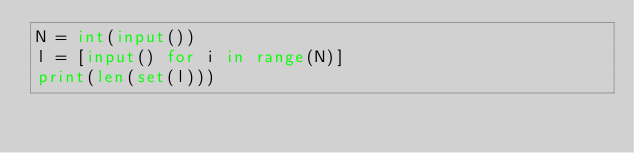Convert code to text. <code><loc_0><loc_0><loc_500><loc_500><_Python_>N = int(input())
l = [input() for i in range(N)]
print(len(set(l)))
</code> 